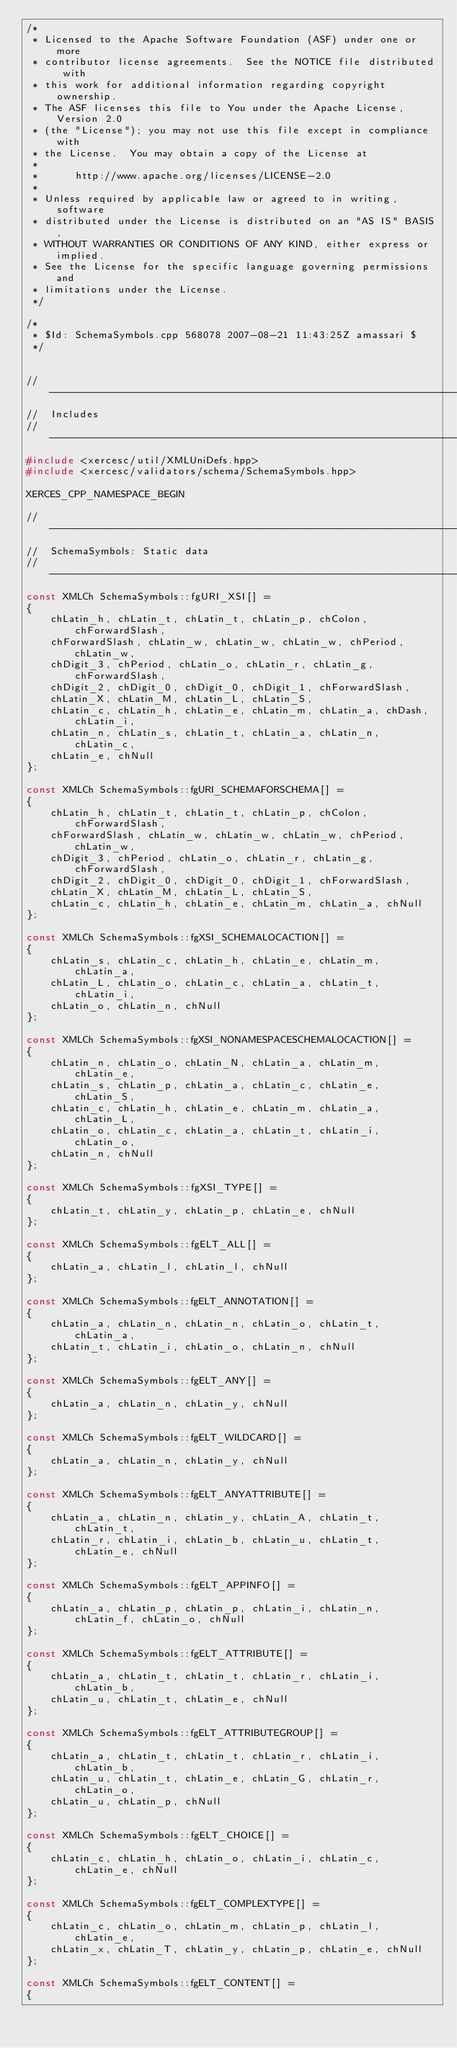<code> <loc_0><loc_0><loc_500><loc_500><_C++_>/*
 * Licensed to the Apache Software Foundation (ASF) under one or more
 * contributor license agreements.  See the NOTICE file distributed with
 * this work for additional information regarding copyright ownership.
 * The ASF licenses this file to You under the Apache License, Version 2.0
 * (the "License"); you may not use this file except in compliance with
 * the License.  You may obtain a copy of the License at
 * 
 *      http://www.apache.org/licenses/LICENSE-2.0
 * 
 * Unless required by applicable law or agreed to in writing, software
 * distributed under the License is distributed on an "AS IS" BASIS,
 * WITHOUT WARRANTIES OR CONDITIONS OF ANY KIND, either express or implied.
 * See the License for the specific language governing permissions and
 * limitations under the License.
 */

/*
 * $Id: SchemaSymbols.cpp 568078 2007-08-21 11:43:25Z amassari $
 */


// ---------------------------------------------------------------------------
//  Includes
// ---------------------------------------------------------------------------
#include <xercesc/util/XMLUniDefs.hpp>
#include <xercesc/validators/schema/SchemaSymbols.hpp>

XERCES_CPP_NAMESPACE_BEGIN

// ---------------------------------------------------------------------------
//  SchemaSymbols: Static data
// ---------------------------------------------------------------------------
const XMLCh SchemaSymbols::fgURI_XSI[] =
{
    chLatin_h, chLatin_t, chLatin_t, chLatin_p, chColon, chForwardSlash,
    chForwardSlash, chLatin_w, chLatin_w, chLatin_w, chPeriod, chLatin_w,
    chDigit_3, chPeriod, chLatin_o, chLatin_r, chLatin_g, chForwardSlash,
    chDigit_2, chDigit_0, chDigit_0, chDigit_1, chForwardSlash,
    chLatin_X, chLatin_M, chLatin_L, chLatin_S,
    chLatin_c, chLatin_h, chLatin_e, chLatin_m, chLatin_a, chDash, chLatin_i,
    chLatin_n, chLatin_s, chLatin_t, chLatin_a, chLatin_n, chLatin_c,
    chLatin_e, chNull
};

const XMLCh SchemaSymbols::fgURI_SCHEMAFORSCHEMA[] =
{
    chLatin_h, chLatin_t, chLatin_t, chLatin_p, chColon, chForwardSlash,
    chForwardSlash, chLatin_w, chLatin_w, chLatin_w, chPeriod, chLatin_w,
    chDigit_3, chPeriod, chLatin_o, chLatin_r, chLatin_g, chForwardSlash,
    chDigit_2, chDigit_0, chDigit_0, chDigit_1, chForwardSlash,
    chLatin_X, chLatin_M, chLatin_L, chLatin_S,
    chLatin_c, chLatin_h, chLatin_e, chLatin_m, chLatin_a, chNull
};

const XMLCh SchemaSymbols::fgXSI_SCHEMALOCACTION[] =
{
    chLatin_s, chLatin_c, chLatin_h, chLatin_e, chLatin_m, chLatin_a,
    chLatin_L, chLatin_o, chLatin_c, chLatin_a, chLatin_t, chLatin_i,
    chLatin_o, chLatin_n, chNull
};

const XMLCh SchemaSymbols::fgXSI_NONAMESPACESCHEMALOCACTION[] =
{
    chLatin_n, chLatin_o, chLatin_N, chLatin_a, chLatin_m, chLatin_e,
    chLatin_s, chLatin_p, chLatin_a, chLatin_c, chLatin_e, chLatin_S,
    chLatin_c, chLatin_h, chLatin_e, chLatin_m, chLatin_a, chLatin_L,
    chLatin_o, chLatin_c, chLatin_a, chLatin_t, chLatin_i, chLatin_o,
    chLatin_n, chNull
};

const XMLCh SchemaSymbols::fgXSI_TYPE[] =
{
    chLatin_t, chLatin_y, chLatin_p, chLatin_e, chNull
};

const XMLCh SchemaSymbols::fgELT_ALL[] =
{
    chLatin_a, chLatin_l, chLatin_l, chNull
};

const XMLCh SchemaSymbols::fgELT_ANNOTATION[] =
{
    chLatin_a, chLatin_n, chLatin_n, chLatin_o, chLatin_t, chLatin_a,
    chLatin_t, chLatin_i, chLatin_o, chLatin_n, chNull
};

const XMLCh SchemaSymbols::fgELT_ANY[] =
{
    chLatin_a, chLatin_n, chLatin_y, chNull
};

const XMLCh SchemaSymbols::fgELT_WILDCARD[] =
{
    chLatin_a, chLatin_n, chLatin_y, chNull
};

const XMLCh SchemaSymbols::fgELT_ANYATTRIBUTE[] =
{
    chLatin_a, chLatin_n, chLatin_y, chLatin_A, chLatin_t, chLatin_t,
    chLatin_r, chLatin_i, chLatin_b, chLatin_u, chLatin_t, chLatin_e, chNull
};

const XMLCh SchemaSymbols::fgELT_APPINFO[] =
{
    chLatin_a, chLatin_p, chLatin_p, chLatin_i, chLatin_n, chLatin_f, chLatin_o, chNull
};

const XMLCh SchemaSymbols::fgELT_ATTRIBUTE[] =
{
    chLatin_a, chLatin_t, chLatin_t, chLatin_r, chLatin_i, chLatin_b,
    chLatin_u, chLatin_t, chLatin_e, chNull
};

const XMLCh SchemaSymbols::fgELT_ATTRIBUTEGROUP[] =
{
    chLatin_a, chLatin_t, chLatin_t, chLatin_r, chLatin_i, chLatin_b,
    chLatin_u, chLatin_t, chLatin_e, chLatin_G, chLatin_r, chLatin_o,
    chLatin_u, chLatin_p, chNull
};

const XMLCh SchemaSymbols::fgELT_CHOICE[] =
{
    chLatin_c, chLatin_h, chLatin_o, chLatin_i, chLatin_c, chLatin_e, chNull
};

const XMLCh SchemaSymbols::fgELT_COMPLEXTYPE[] =
{
    chLatin_c, chLatin_o, chLatin_m, chLatin_p, chLatin_l, chLatin_e,
    chLatin_x, chLatin_T, chLatin_y, chLatin_p, chLatin_e, chNull
};

const XMLCh SchemaSymbols::fgELT_CONTENT[] =
{</code> 